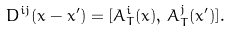Convert formula to latex. <formula><loc_0><loc_0><loc_500><loc_500>D ^ { i j } ( x - x ^ { \prime } ) = [ \bar { A } _ { T } ^ { i } ( x ) , \, \bar { A } _ { T } ^ { j } ( x ^ { \prime } ) ] .</formula> 